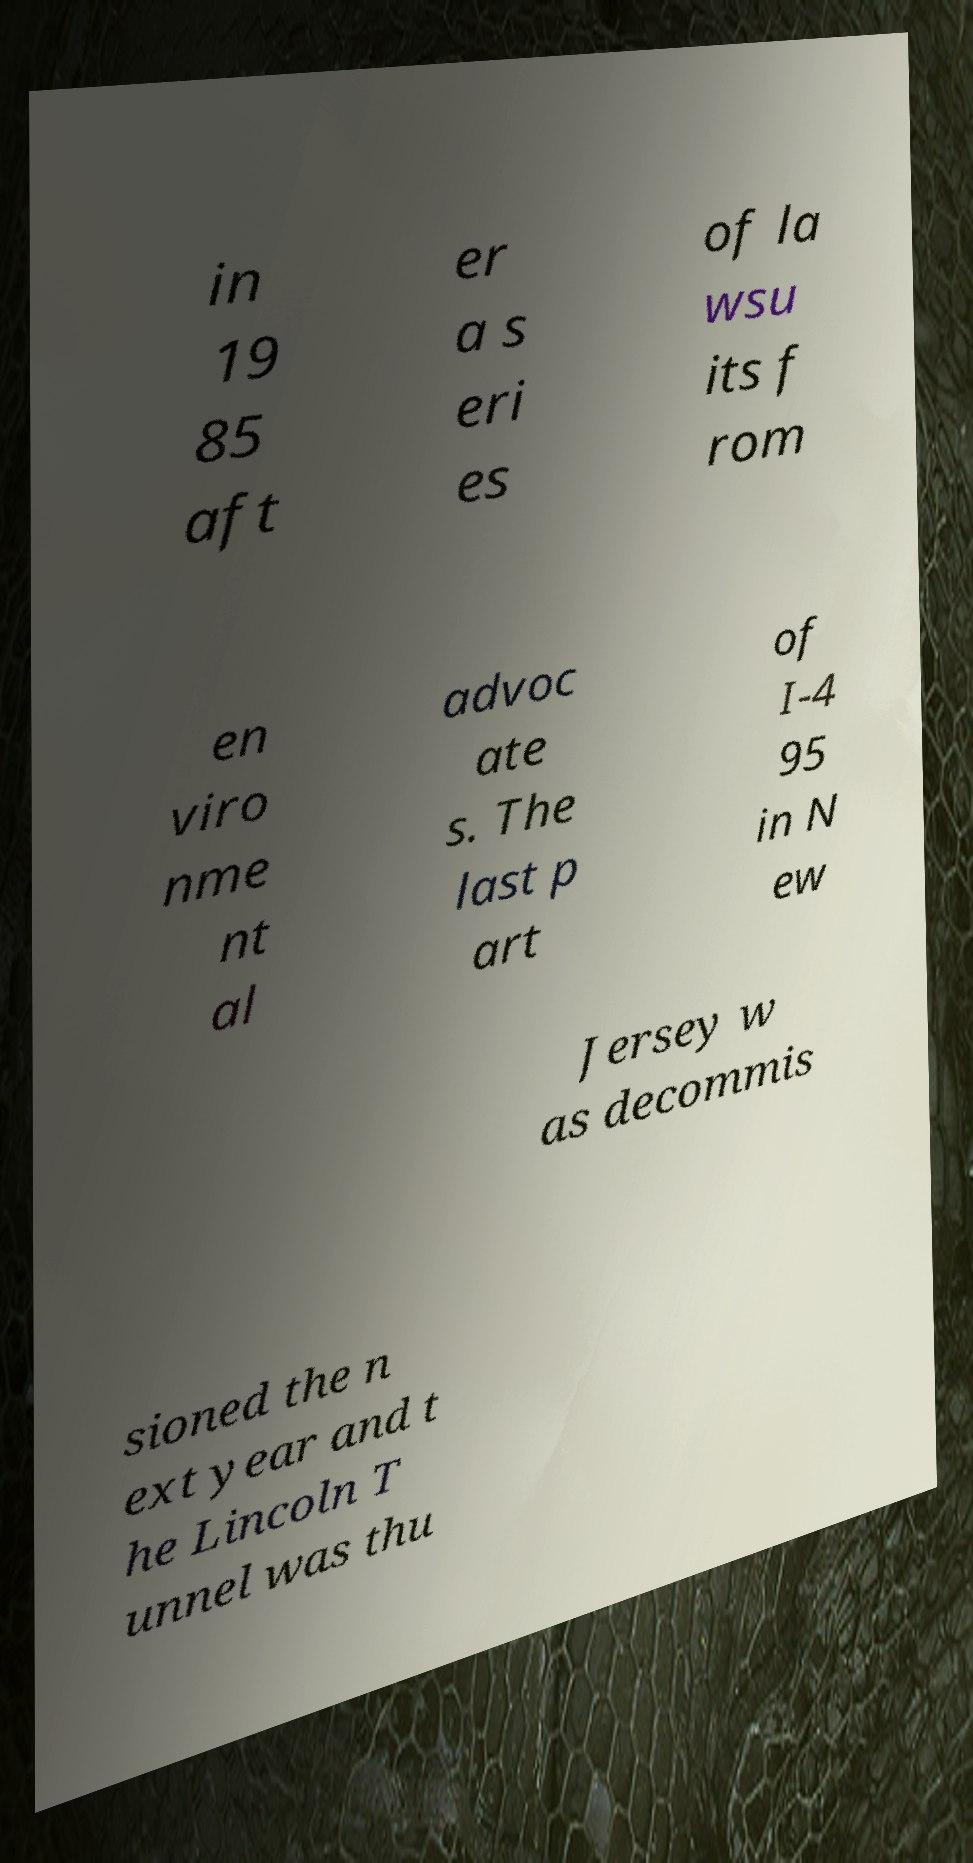I need the written content from this picture converted into text. Can you do that? in 19 85 aft er a s eri es of la wsu its f rom en viro nme nt al advoc ate s. The last p art of I-4 95 in N ew Jersey w as decommis sioned the n ext year and t he Lincoln T unnel was thu 